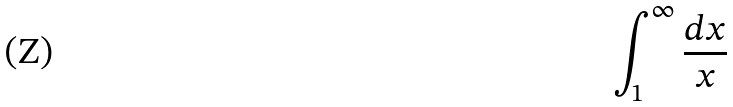<formula> <loc_0><loc_0><loc_500><loc_500>\int _ { 1 } ^ { \infty } \frac { d x } { x }</formula> 